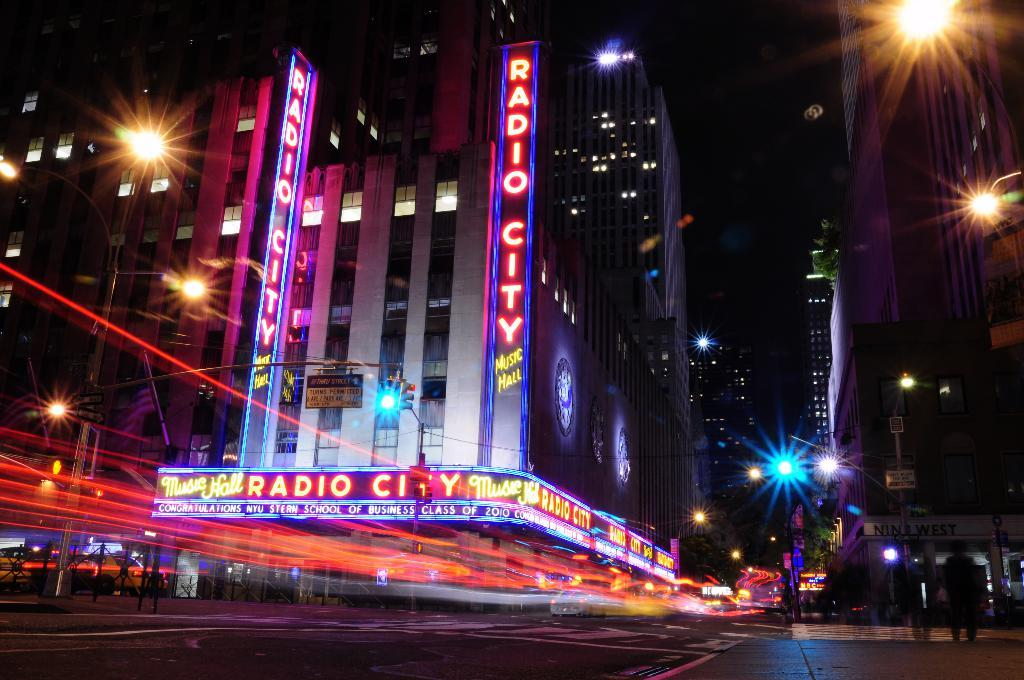What type of structures can be seen in the image? There are buildings in the image. What can be seen illuminating the area in the image? There are street lights in the image. What activity are people engaged in within the image? There are people walking on the road in the image. How many pairs of shoes can be seen on the street in the image? There is no mention of shoes in the image, so it is not possible to determine how many pairs are present. 